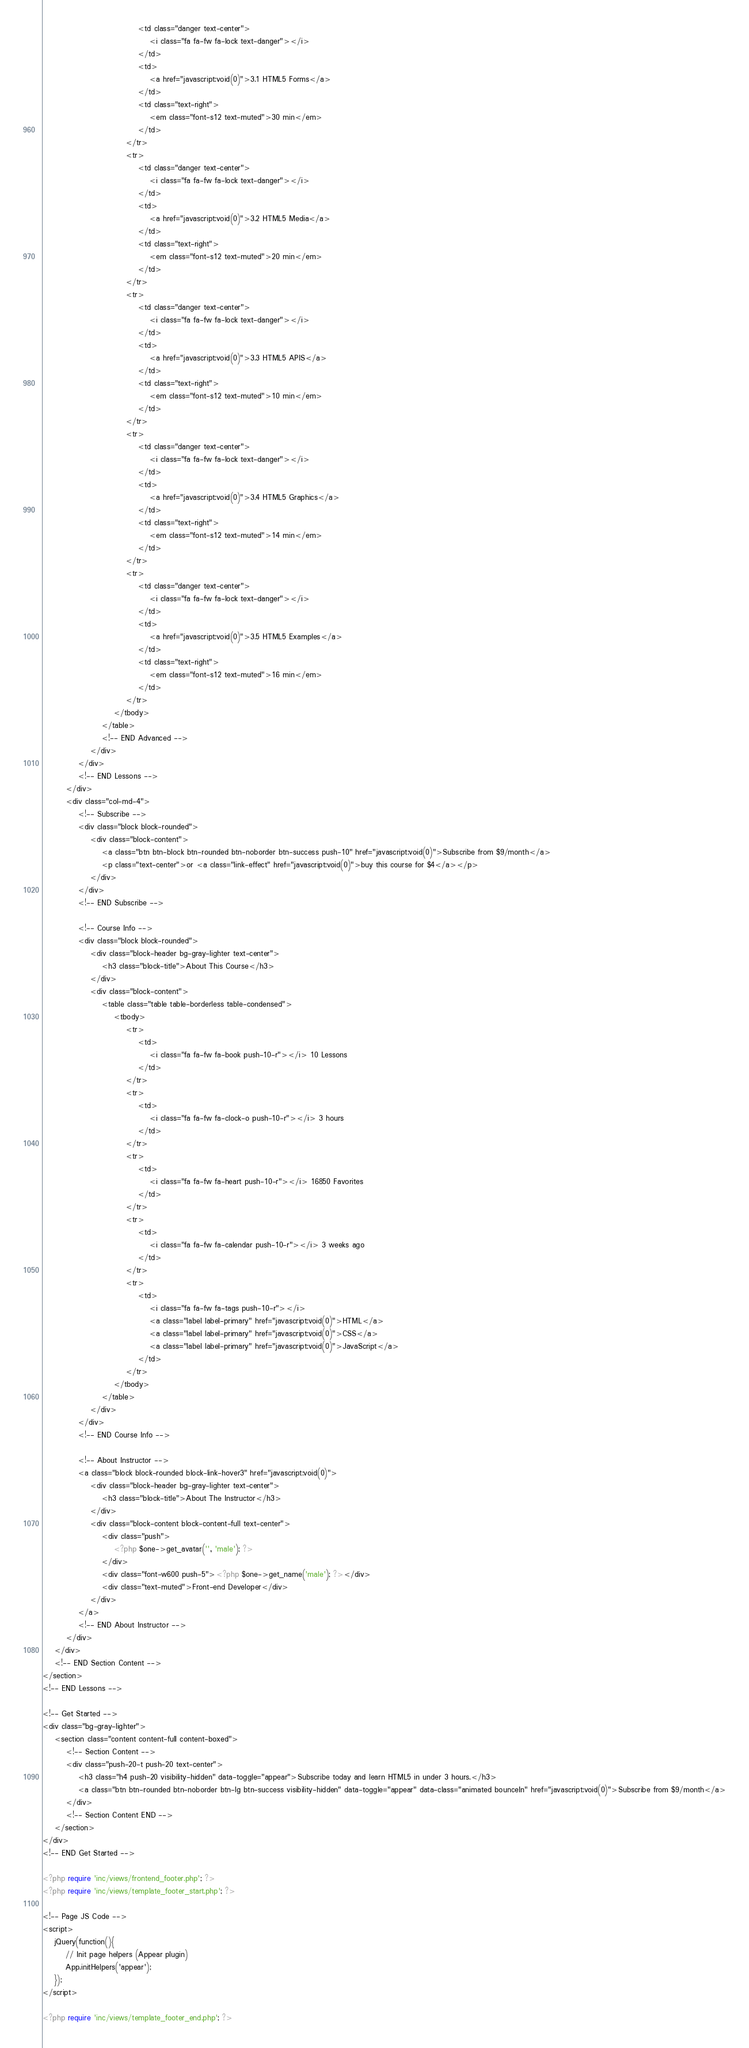Convert code to text. <code><loc_0><loc_0><loc_500><loc_500><_PHP_>                                <td class="danger text-center">
                                    <i class="fa fa-fw fa-lock text-danger"></i>
                                </td>
                                <td>
                                    <a href="javascript:void(0)">3.1 HTML5 Forms</a>
                                </td>
                                <td class="text-right">
                                    <em class="font-s12 text-muted">30 min</em>
                                </td>
                            </tr>
                            <tr>
                                <td class="danger text-center">
                                    <i class="fa fa-fw fa-lock text-danger"></i>
                                </td>
                                <td>
                                    <a href="javascript:void(0)">3.2 HTML5 Media</a>
                                </td>
                                <td class="text-right">
                                    <em class="font-s12 text-muted">20 min</em>
                                </td>
                            </tr>
                            <tr>
                                <td class="danger text-center">
                                    <i class="fa fa-fw fa-lock text-danger"></i>
                                </td>
                                <td>
                                    <a href="javascript:void(0)">3.3 HTML5 APIS</a>
                                </td>
                                <td class="text-right">
                                    <em class="font-s12 text-muted">10 min</em>
                                </td>
                            </tr>
                            <tr>
                                <td class="danger text-center">
                                    <i class="fa fa-fw fa-lock text-danger"></i>
                                </td>
                                <td>
                                    <a href="javascript:void(0)">3.4 HTML5 Graphics</a>
                                </td>
                                <td class="text-right">
                                    <em class="font-s12 text-muted">14 min</em>
                                </td>
                            </tr>
                            <tr>
                                <td class="danger text-center">
                                    <i class="fa fa-fw fa-lock text-danger"></i>
                                </td>
                                <td>
                                    <a href="javascript:void(0)">3.5 HTML5 Examples</a>
                                </td>
                                <td class="text-right">
                                    <em class="font-s12 text-muted">16 min</em>
                                </td>
                            </tr>
                        </tbody>
                    </table>
                    <!-- END Advanced -->
                </div>
            </div>
            <!-- END Lessons -->
        </div>
        <div class="col-md-4">
            <!-- Subscribe -->
            <div class="block block-rounded">
                <div class="block-content">
                    <a class="btn btn-block btn-rounded btn-noborder btn-success push-10" href="javascript:void(0)">Subscribe from $9/month</a>
                    <p class="text-center">or <a class="link-effect" href="javascript:void(0)">buy this course for $4</a></p>
                </div>
            </div>
            <!-- END Subscribe -->

            <!-- Course Info -->
            <div class="block block-rounded">
                <div class="block-header bg-gray-lighter text-center">
                    <h3 class="block-title">About This Course</h3>
                </div>
                <div class="block-content">
                    <table class="table table-borderless table-condensed">
                        <tbody>
                            <tr>
                                <td>
                                    <i class="fa fa-fw fa-book push-10-r"></i> 10 Lessons
                                </td>
                            </tr>
                            <tr>
                                <td>
                                    <i class="fa fa-fw fa-clock-o push-10-r"></i> 3 hours
                                </td>
                            </tr>
                            <tr>
                                <td>
                                    <i class="fa fa-fw fa-heart push-10-r"></i> 16850 Favorites
                                </td>
                            </tr>
                            <tr>
                                <td>
                                    <i class="fa fa-fw fa-calendar push-10-r"></i> 3 weeks ago
                                </td>
                            </tr>
                            <tr>
                                <td>
                                    <i class="fa fa-fw fa-tags push-10-r"></i>
                                    <a class="label label-primary" href="javascript:void(0)">HTML</a>
                                    <a class="label label-primary" href="javascript:void(0)">CSS</a>
                                    <a class="label label-primary" href="javascript:void(0)">JavaScript</a>
                                </td>
                            </tr>
                        </tbody>
                    </table>
                </div>
            </div>
            <!-- END Course Info -->

            <!-- About Instructor -->
            <a class="block block-rounded block-link-hover3" href="javascript:void(0)">
                <div class="block-header bg-gray-lighter text-center">
                    <h3 class="block-title">About The Instructor</h3>
                </div>
                <div class="block-content block-content-full text-center">
                    <div class="push">
                        <?php $one->get_avatar('', 'male'); ?>
                    </div>
                    <div class="font-w600 push-5"><?php $one->get_name('male'); ?></div>
                    <div class="text-muted">Front-end Developer</div>
                </div>
            </a>
            <!-- END About Instructor -->
        </div>
    </div>
    <!-- END Section Content -->
</section>
<!-- END Lessons -->

<!-- Get Started -->
<div class="bg-gray-lighter">
    <section class="content content-full content-boxed">
        <!-- Section Content -->
        <div class="push-20-t push-20 text-center">
            <h3 class="h4 push-20 visibility-hidden" data-toggle="appear">Subscribe today and learn HTML5 in under 3 hours.</h3>
            <a class="btn btn-rounded btn-noborder btn-lg btn-success visibility-hidden" data-toggle="appear" data-class="animated bounceIn" href="javascript:void(0)">Subscribe from $9/month</a>
        </div>
        <!-- Section Content END -->
    </section>
</div>
<!-- END Get Started -->

<?php require 'inc/views/frontend_footer.php'; ?>
<?php require 'inc/views/template_footer_start.php'; ?>

<!-- Page JS Code -->
<script>
    jQuery(function(){
        // Init page helpers (Appear plugin)
        App.initHelpers('appear');
    });
</script>

<?php require 'inc/views/template_footer_end.php'; ?></code> 